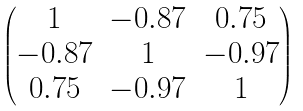Convert formula to latex. <formula><loc_0><loc_0><loc_500><loc_500>\begin{pmatrix} 1 & - 0 . 8 7 & 0 . 7 5 \\ - 0 . 8 7 & 1 & - 0 . 9 7 \\ 0 . 7 5 & - 0 . 9 7 & 1 \end{pmatrix}</formula> 